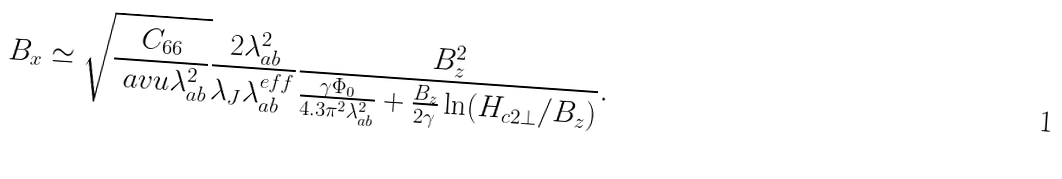<formula> <loc_0><loc_0><loc_500><loc_500>B _ { x } \simeq \sqrt { \frac { C _ { 6 6 } } { \ a v u \lambda _ { a b } ^ { 2 } } } \frac { 2 \lambda _ { a b } ^ { 2 } } { \lambda _ { J } \lambda _ { a b } ^ { e f f } } \frac { B _ { z } ^ { 2 } } { \frac { \gamma \Phi _ { 0 } } { 4 . 3 \pi ^ { 2 } \lambda _ { a b } ^ { 2 } } + \frac { B _ { z } } { 2 \gamma } \ln ( H _ { c 2 \perp } / B _ { z } ) } .</formula> 